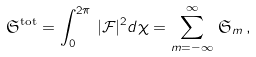<formula> <loc_0><loc_0><loc_500><loc_500>\mathfrak { S } ^ { \text {tot} } = \int _ { 0 } ^ { 2 \pi } \, | \mathcal { F } | ^ { 2 } d \chi = \sum _ { m = - \infty } ^ { \infty } \, \mathfrak { S } _ { m } \, ,</formula> 